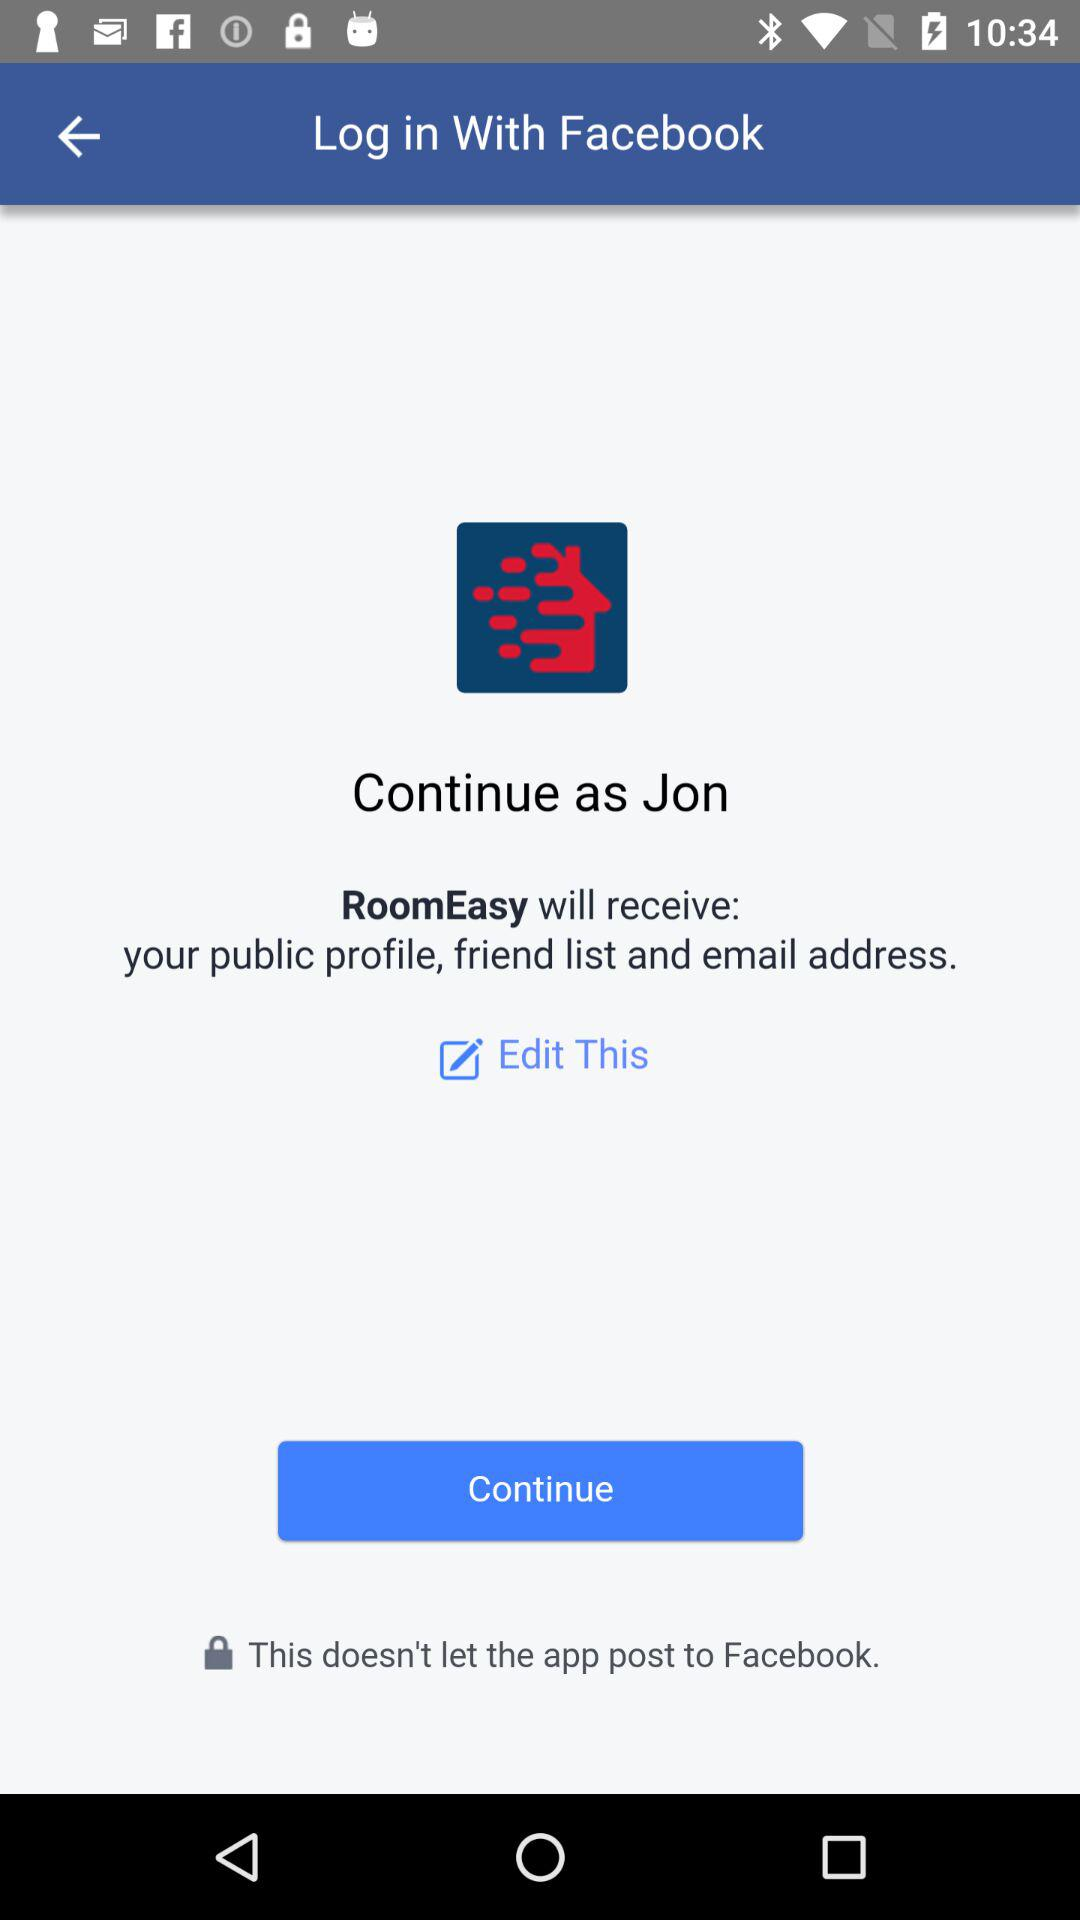What application is asking for permission? The application asking for permission is "RoomEasy". 